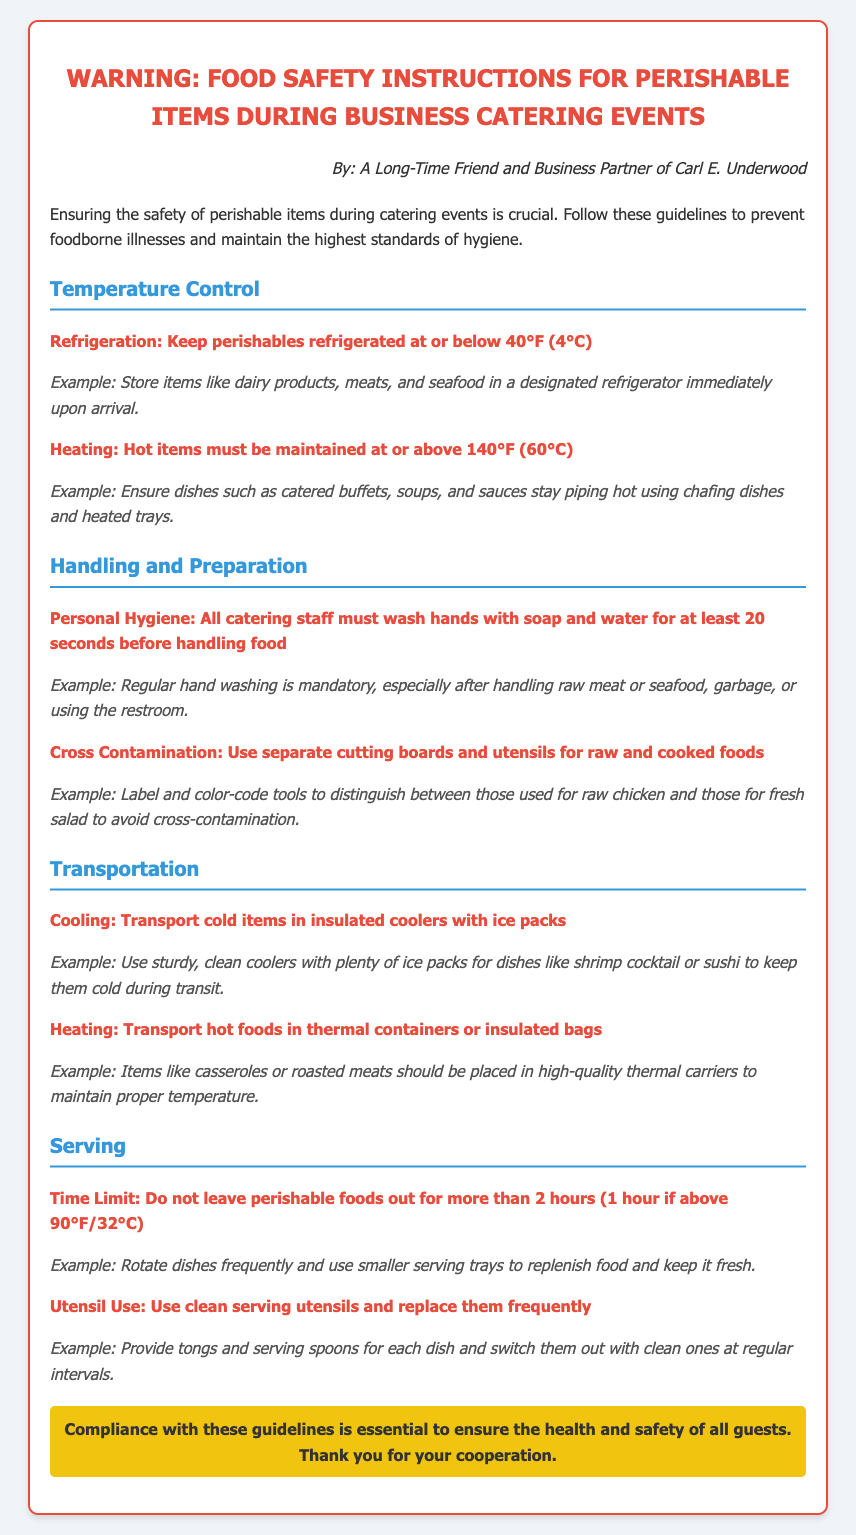What is the refrigeration temperature for perishables? The refrigeration temperature for perishables is stated as being at or below 40°F (4°C).
Answer: 40°F (4°C) What should hot items be maintained at? The document specifies that hot items must be maintained at or above 140°F (60°C).
Answer: 140°F (60°C) What is the maximum time limit for leaving perishable foods out? According to the guidelines, perishable foods should not be left out for more than 2 hours.
Answer: 2 hours What hygiene practice must all catering staff follow? The document mentions that all catering staff must wash hands with soap and water for at least 20 seconds.
Answer: 20 seconds What type of containers should hot foods be transported in? The guidelines indicate that hot foods should be transported in thermal containers or insulated bags.
Answer: Thermal containers Why is it important to use separate cutting boards? The document states that using separate cutting boards prevents cross-contamination between raw and cooked foods.
Answer: Prevent cross-contamination What strategies are suggested for keeping food fresh when serving? The recommendation is to rotate dishes frequently and use smaller serving trays for replenishment.
Answer: Rotate dishes What kind of utensils should be used for serving? The document specifies using clean serving utensils and replacing them frequently.
Answer: Clean serving utensils 